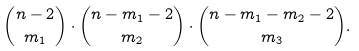Convert formula to latex. <formula><loc_0><loc_0><loc_500><loc_500>\binom { n - 2 } { m _ { 1 } } \cdot \binom { n - m _ { 1 } - 2 } { m _ { 2 } } \cdot \binom { n - m _ { 1 } - m _ { 2 } - 2 } { m _ { 3 } } .</formula> 